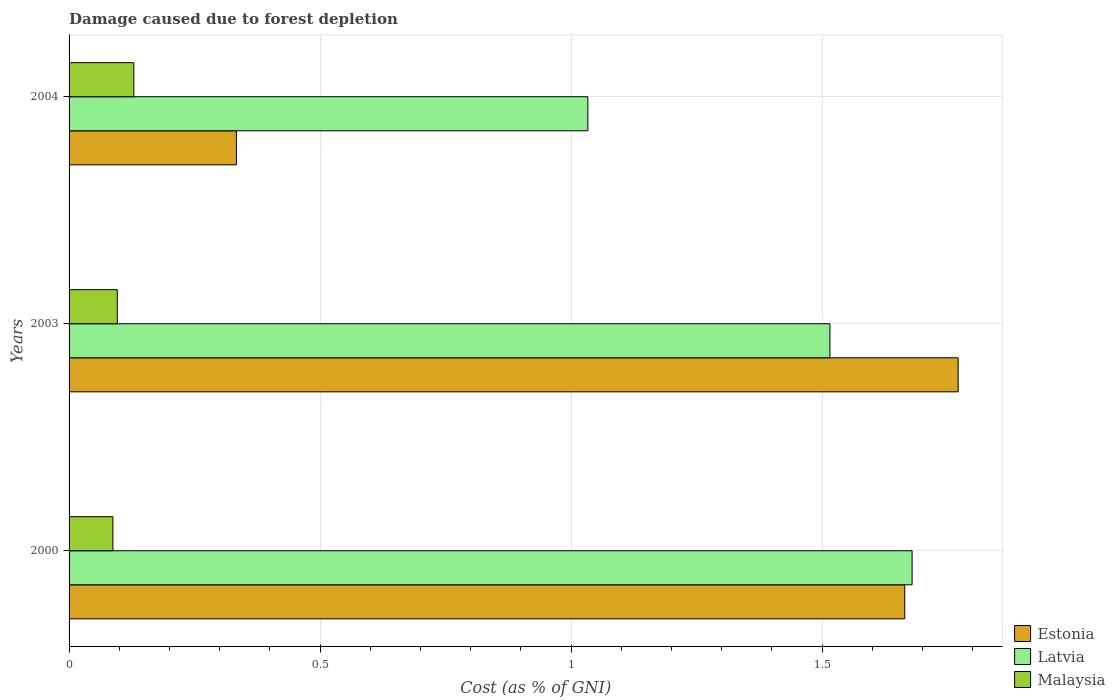How many different coloured bars are there?
Your answer should be very brief. 3. How many bars are there on the 1st tick from the top?
Ensure brevity in your answer.  3. How many bars are there on the 3rd tick from the bottom?
Make the answer very short. 3. In how many cases, is the number of bars for a given year not equal to the number of legend labels?
Your answer should be very brief. 0. What is the cost of damage caused due to forest depletion in Malaysia in 2003?
Your answer should be compact. 0.1. Across all years, what is the maximum cost of damage caused due to forest depletion in Latvia?
Your answer should be very brief. 1.68. Across all years, what is the minimum cost of damage caused due to forest depletion in Latvia?
Make the answer very short. 1.03. In which year was the cost of damage caused due to forest depletion in Estonia maximum?
Offer a very short reply. 2003. In which year was the cost of damage caused due to forest depletion in Malaysia minimum?
Keep it short and to the point. 2000. What is the total cost of damage caused due to forest depletion in Estonia in the graph?
Give a very brief answer. 3.77. What is the difference between the cost of damage caused due to forest depletion in Latvia in 2000 and that in 2004?
Provide a short and direct response. 0.65. What is the difference between the cost of damage caused due to forest depletion in Estonia in 2004 and the cost of damage caused due to forest depletion in Malaysia in 2003?
Give a very brief answer. 0.24. What is the average cost of damage caused due to forest depletion in Latvia per year?
Provide a short and direct response. 1.41. In the year 2003, what is the difference between the cost of damage caused due to forest depletion in Estonia and cost of damage caused due to forest depletion in Latvia?
Make the answer very short. 0.26. What is the ratio of the cost of damage caused due to forest depletion in Latvia in 2000 to that in 2003?
Make the answer very short. 1.11. Is the difference between the cost of damage caused due to forest depletion in Estonia in 2000 and 2004 greater than the difference between the cost of damage caused due to forest depletion in Latvia in 2000 and 2004?
Keep it short and to the point. Yes. What is the difference between the highest and the second highest cost of damage caused due to forest depletion in Malaysia?
Give a very brief answer. 0.03. What is the difference between the highest and the lowest cost of damage caused due to forest depletion in Estonia?
Keep it short and to the point. 1.44. What does the 3rd bar from the top in 2003 represents?
Give a very brief answer. Estonia. What does the 1st bar from the bottom in 2000 represents?
Provide a short and direct response. Estonia. Is it the case that in every year, the sum of the cost of damage caused due to forest depletion in Malaysia and cost of damage caused due to forest depletion in Latvia is greater than the cost of damage caused due to forest depletion in Estonia?
Ensure brevity in your answer.  No. How many bars are there?
Keep it short and to the point. 9. What is the difference between two consecutive major ticks on the X-axis?
Your response must be concise. 0.5. Does the graph contain any zero values?
Give a very brief answer. No. Where does the legend appear in the graph?
Your response must be concise. Bottom right. How many legend labels are there?
Keep it short and to the point. 3. What is the title of the graph?
Ensure brevity in your answer.  Damage caused due to forest depletion. Does "Uzbekistan" appear as one of the legend labels in the graph?
Provide a succinct answer. No. What is the label or title of the X-axis?
Offer a very short reply. Cost (as % of GNI). What is the Cost (as % of GNI) in Estonia in 2000?
Your response must be concise. 1.66. What is the Cost (as % of GNI) of Latvia in 2000?
Your answer should be very brief. 1.68. What is the Cost (as % of GNI) in Malaysia in 2000?
Keep it short and to the point. 0.09. What is the Cost (as % of GNI) of Estonia in 2003?
Offer a terse response. 1.77. What is the Cost (as % of GNI) in Latvia in 2003?
Provide a succinct answer. 1.52. What is the Cost (as % of GNI) in Malaysia in 2003?
Your answer should be compact. 0.1. What is the Cost (as % of GNI) of Estonia in 2004?
Your response must be concise. 0.33. What is the Cost (as % of GNI) of Latvia in 2004?
Make the answer very short. 1.03. What is the Cost (as % of GNI) of Malaysia in 2004?
Ensure brevity in your answer.  0.13. Across all years, what is the maximum Cost (as % of GNI) of Estonia?
Offer a very short reply. 1.77. Across all years, what is the maximum Cost (as % of GNI) in Latvia?
Your response must be concise. 1.68. Across all years, what is the maximum Cost (as % of GNI) of Malaysia?
Offer a terse response. 0.13. Across all years, what is the minimum Cost (as % of GNI) in Estonia?
Give a very brief answer. 0.33. Across all years, what is the minimum Cost (as % of GNI) of Latvia?
Make the answer very short. 1.03. Across all years, what is the minimum Cost (as % of GNI) in Malaysia?
Your response must be concise. 0.09. What is the total Cost (as % of GNI) of Estonia in the graph?
Keep it short and to the point. 3.77. What is the total Cost (as % of GNI) of Latvia in the graph?
Give a very brief answer. 4.23. What is the total Cost (as % of GNI) in Malaysia in the graph?
Ensure brevity in your answer.  0.31. What is the difference between the Cost (as % of GNI) in Estonia in 2000 and that in 2003?
Give a very brief answer. -0.11. What is the difference between the Cost (as % of GNI) of Latvia in 2000 and that in 2003?
Ensure brevity in your answer.  0.16. What is the difference between the Cost (as % of GNI) of Malaysia in 2000 and that in 2003?
Offer a very short reply. -0.01. What is the difference between the Cost (as % of GNI) of Estonia in 2000 and that in 2004?
Your answer should be compact. 1.33. What is the difference between the Cost (as % of GNI) of Latvia in 2000 and that in 2004?
Your answer should be compact. 0.65. What is the difference between the Cost (as % of GNI) of Malaysia in 2000 and that in 2004?
Provide a succinct answer. -0.04. What is the difference between the Cost (as % of GNI) of Estonia in 2003 and that in 2004?
Keep it short and to the point. 1.44. What is the difference between the Cost (as % of GNI) of Latvia in 2003 and that in 2004?
Ensure brevity in your answer.  0.48. What is the difference between the Cost (as % of GNI) of Malaysia in 2003 and that in 2004?
Offer a terse response. -0.03. What is the difference between the Cost (as % of GNI) of Estonia in 2000 and the Cost (as % of GNI) of Latvia in 2003?
Ensure brevity in your answer.  0.15. What is the difference between the Cost (as % of GNI) of Estonia in 2000 and the Cost (as % of GNI) of Malaysia in 2003?
Offer a terse response. 1.57. What is the difference between the Cost (as % of GNI) in Latvia in 2000 and the Cost (as % of GNI) in Malaysia in 2003?
Your response must be concise. 1.58. What is the difference between the Cost (as % of GNI) in Estonia in 2000 and the Cost (as % of GNI) in Latvia in 2004?
Offer a terse response. 0.63. What is the difference between the Cost (as % of GNI) of Estonia in 2000 and the Cost (as % of GNI) of Malaysia in 2004?
Make the answer very short. 1.54. What is the difference between the Cost (as % of GNI) of Latvia in 2000 and the Cost (as % of GNI) of Malaysia in 2004?
Provide a succinct answer. 1.55. What is the difference between the Cost (as % of GNI) in Estonia in 2003 and the Cost (as % of GNI) in Latvia in 2004?
Your answer should be compact. 0.74. What is the difference between the Cost (as % of GNI) in Estonia in 2003 and the Cost (as % of GNI) in Malaysia in 2004?
Offer a very short reply. 1.64. What is the difference between the Cost (as % of GNI) of Latvia in 2003 and the Cost (as % of GNI) of Malaysia in 2004?
Your answer should be very brief. 1.39. What is the average Cost (as % of GNI) in Estonia per year?
Make the answer very short. 1.26. What is the average Cost (as % of GNI) in Latvia per year?
Your answer should be compact. 1.41. What is the average Cost (as % of GNI) of Malaysia per year?
Your answer should be very brief. 0.1. In the year 2000, what is the difference between the Cost (as % of GNI) of Estonia and Cost (as % of GNI) of Latvia?
Offer a very short reply. -0.01. In the year 2000, what is the difference between the Cost (as % of GNI) of Estonia and Cost (as % of GNI) of Malaysia?
Keep it short and to the point. 1.58. In the year 2000, what is the difference between the Cost (as % of GNI) of Latvia and Cost (as % of GNI) of Malaysia?
Provide a succinct answer. 1.59. In the year 2003, what is the difference between the Cost (as % of GNI) of Estonia and Cost (as % of GNI) of Latvia?
Make the answer very short. 0.26. In the year 2003, what is the difference between the Cost (as % of GNI) in Estonia and Cost (as % of GNI) in Malaysia?
Provide a succinct answer. 1.67. In the year 2003, what is the difference between the Cost (as % of GNI) of Latvia and Cost (as % of GNI) of Malaysia?
Provide a short and direct response. 1.42. In the year 2004, what is the difference between the Cost (as % of GNI) in Estonia and Cost (as % of GNI) in Latvia?
Your answer should be very brief. -0.7. In the year 2004, what is the difference between the Cost (as % of GNI) in Estonia and Cost (as % of GNI) in Malaysia?
Your response must be concise. 0.2. In the year 2004, what is the difference between the Cost (as % of GNI) in Latvia and Cost (as % of GNI) in Malaysia?
Offer a very short reply. 0.9. What is the ratio of the Cost (as % of GNI) of Estonia in 2000 to that in 2003?
Your response must be concise. 0.94. What is the ratio of the Cost (as % of GNI) in Latvia in 2000 to that in 2003?
Provide a short and direct response. 1.11. What is the ratio of the Cost (as % of GNI) of Malaysia in 2000 to that in 2003?
Keep it short and to the point. 0.91. What is the ratio of the Cost (as % of GNI) in Estonia in 2000 to that in 2004?
Make the answer very short. 4.99. What is the ratio of the Cost (as % of GNI) in Latvia in 2000 to that in 2004?
Keep it short and to the point. 1.62. What is the ratio of the Cost (as % of GNI) in Malaysia in 2000 to that in 2004?
Your answer should be compact. 0.68. What is the ratio of the Cost (as % of GNI) in Estonia in 2003 to that in 2004?
Your response must be concise. 5.31. What is the ratio of the Cost (as % of GNI) of Latvia in 2003 to that in 2004?
Provide a short and direct response. 1.47. What is the ratio of the Cost (as % of GNI) of Malaysia in 2003 to that in 2004?
Provide a short and direct response. 0.74. What is the difference between the highest and the second highest Cost (as % of GNI) of Estonia?
Your answer should be very brief. 0.11. What is the difference between the highest and the second highest Cost (as % of GNI) in Latvia?
Your answer should be compact. 0.16. What is the difference between the highest and the second highest Cost (as % of GNI) in Malaysia?
Make the answer very short. 0.03. What is the difference between the highest and the lowest Cost (as % of GNI) of Estonia?
Your answer should be compact. 1.44. What is the difference between the highest and the lowest Cost (as % of GNI) in Latvia?
Your response must be concise. 0.65. What is the difference between the highest and the lowest Cost (as % of GNI) of Malaysia?
Give a very brief answer. 0.04. 